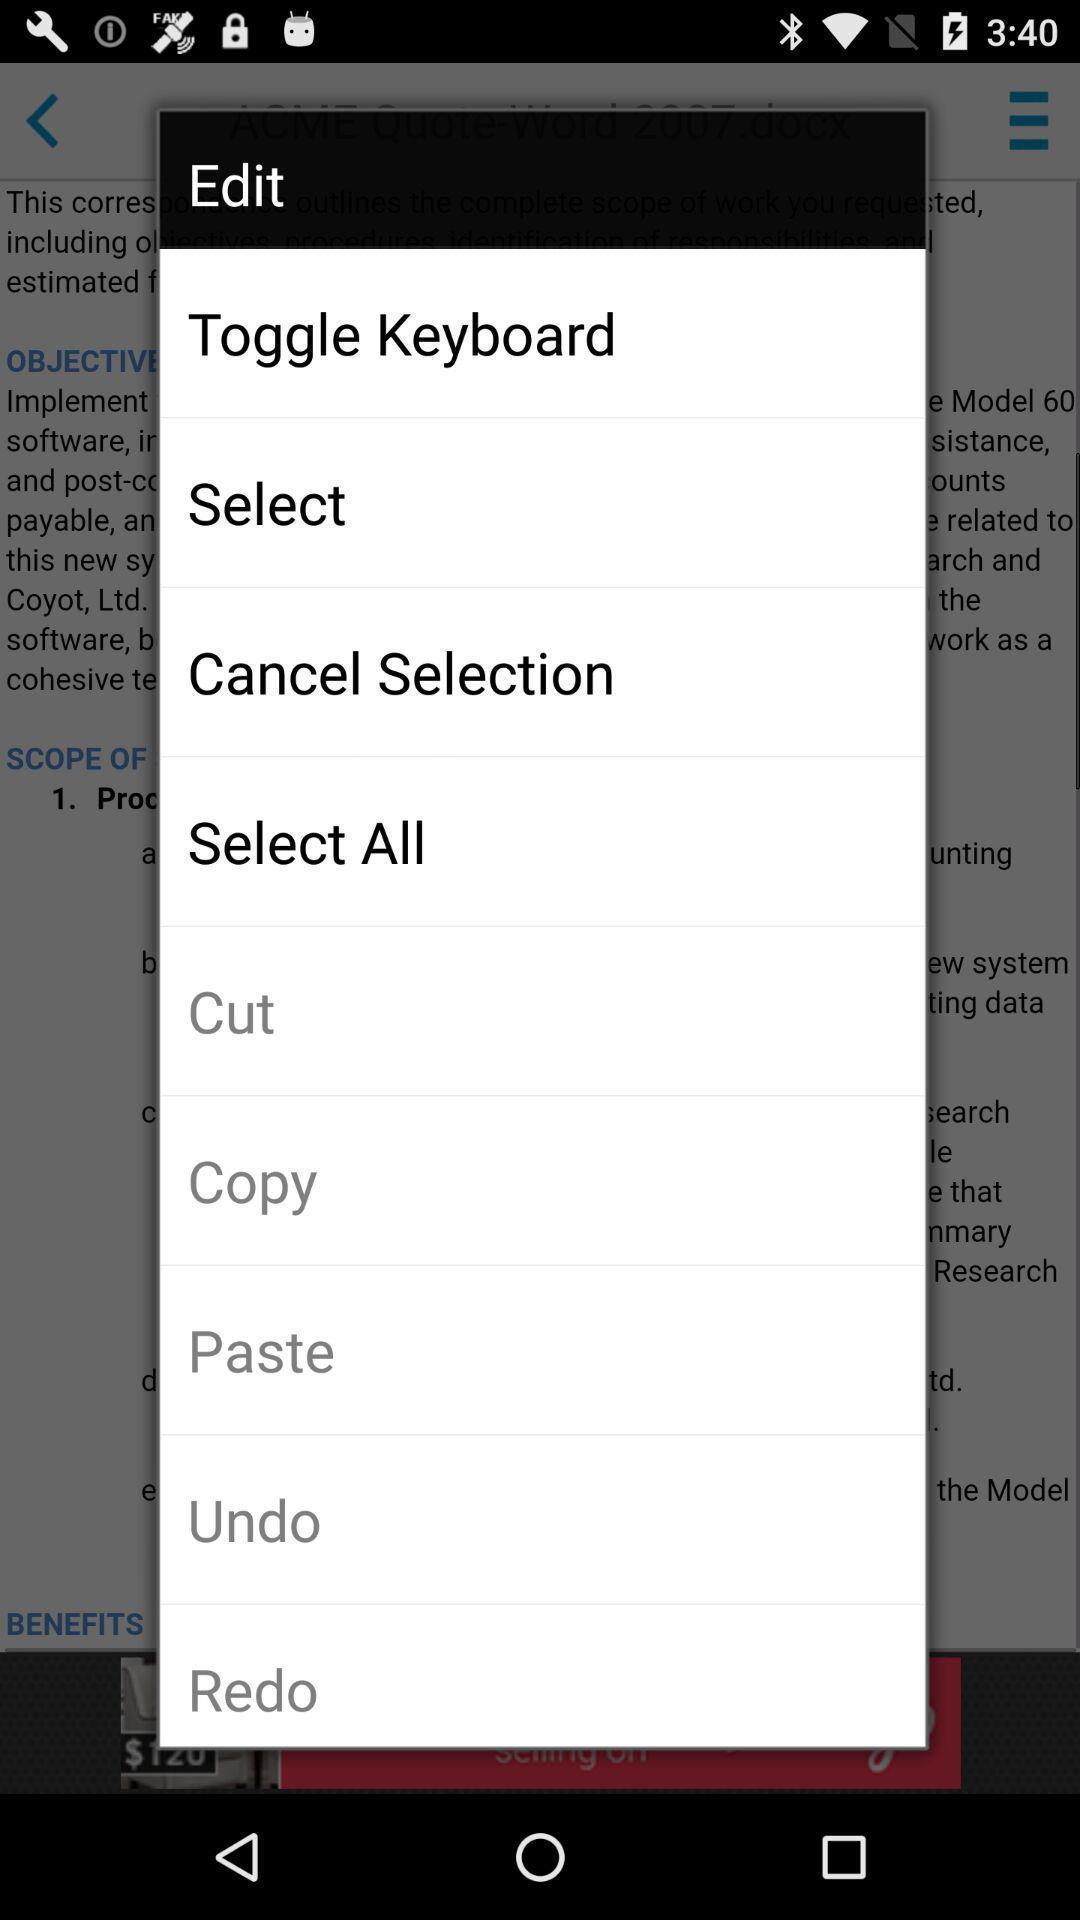Give me a narrative description of this picture. Pop-up shows various option for edit. 